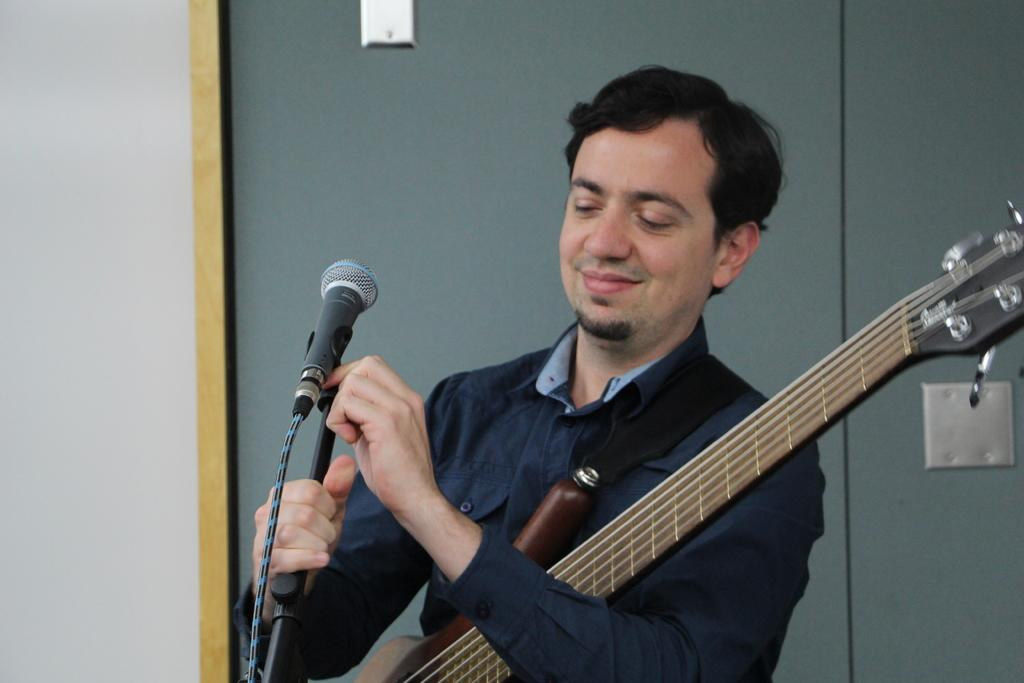What is the person holding in the image? The person is holding a guitar and a microphone. What is the purpose of the microphone with a stand in the image? The microphone with a stand is likely used for amplifying the person's voice during a performance. What can be seen in the background of the image? There is a wall in the background. What type of clouds can be seen in the image? There are no clouds visible in the image. What is the condition of the juice in the image? There is no juice present in the image. 